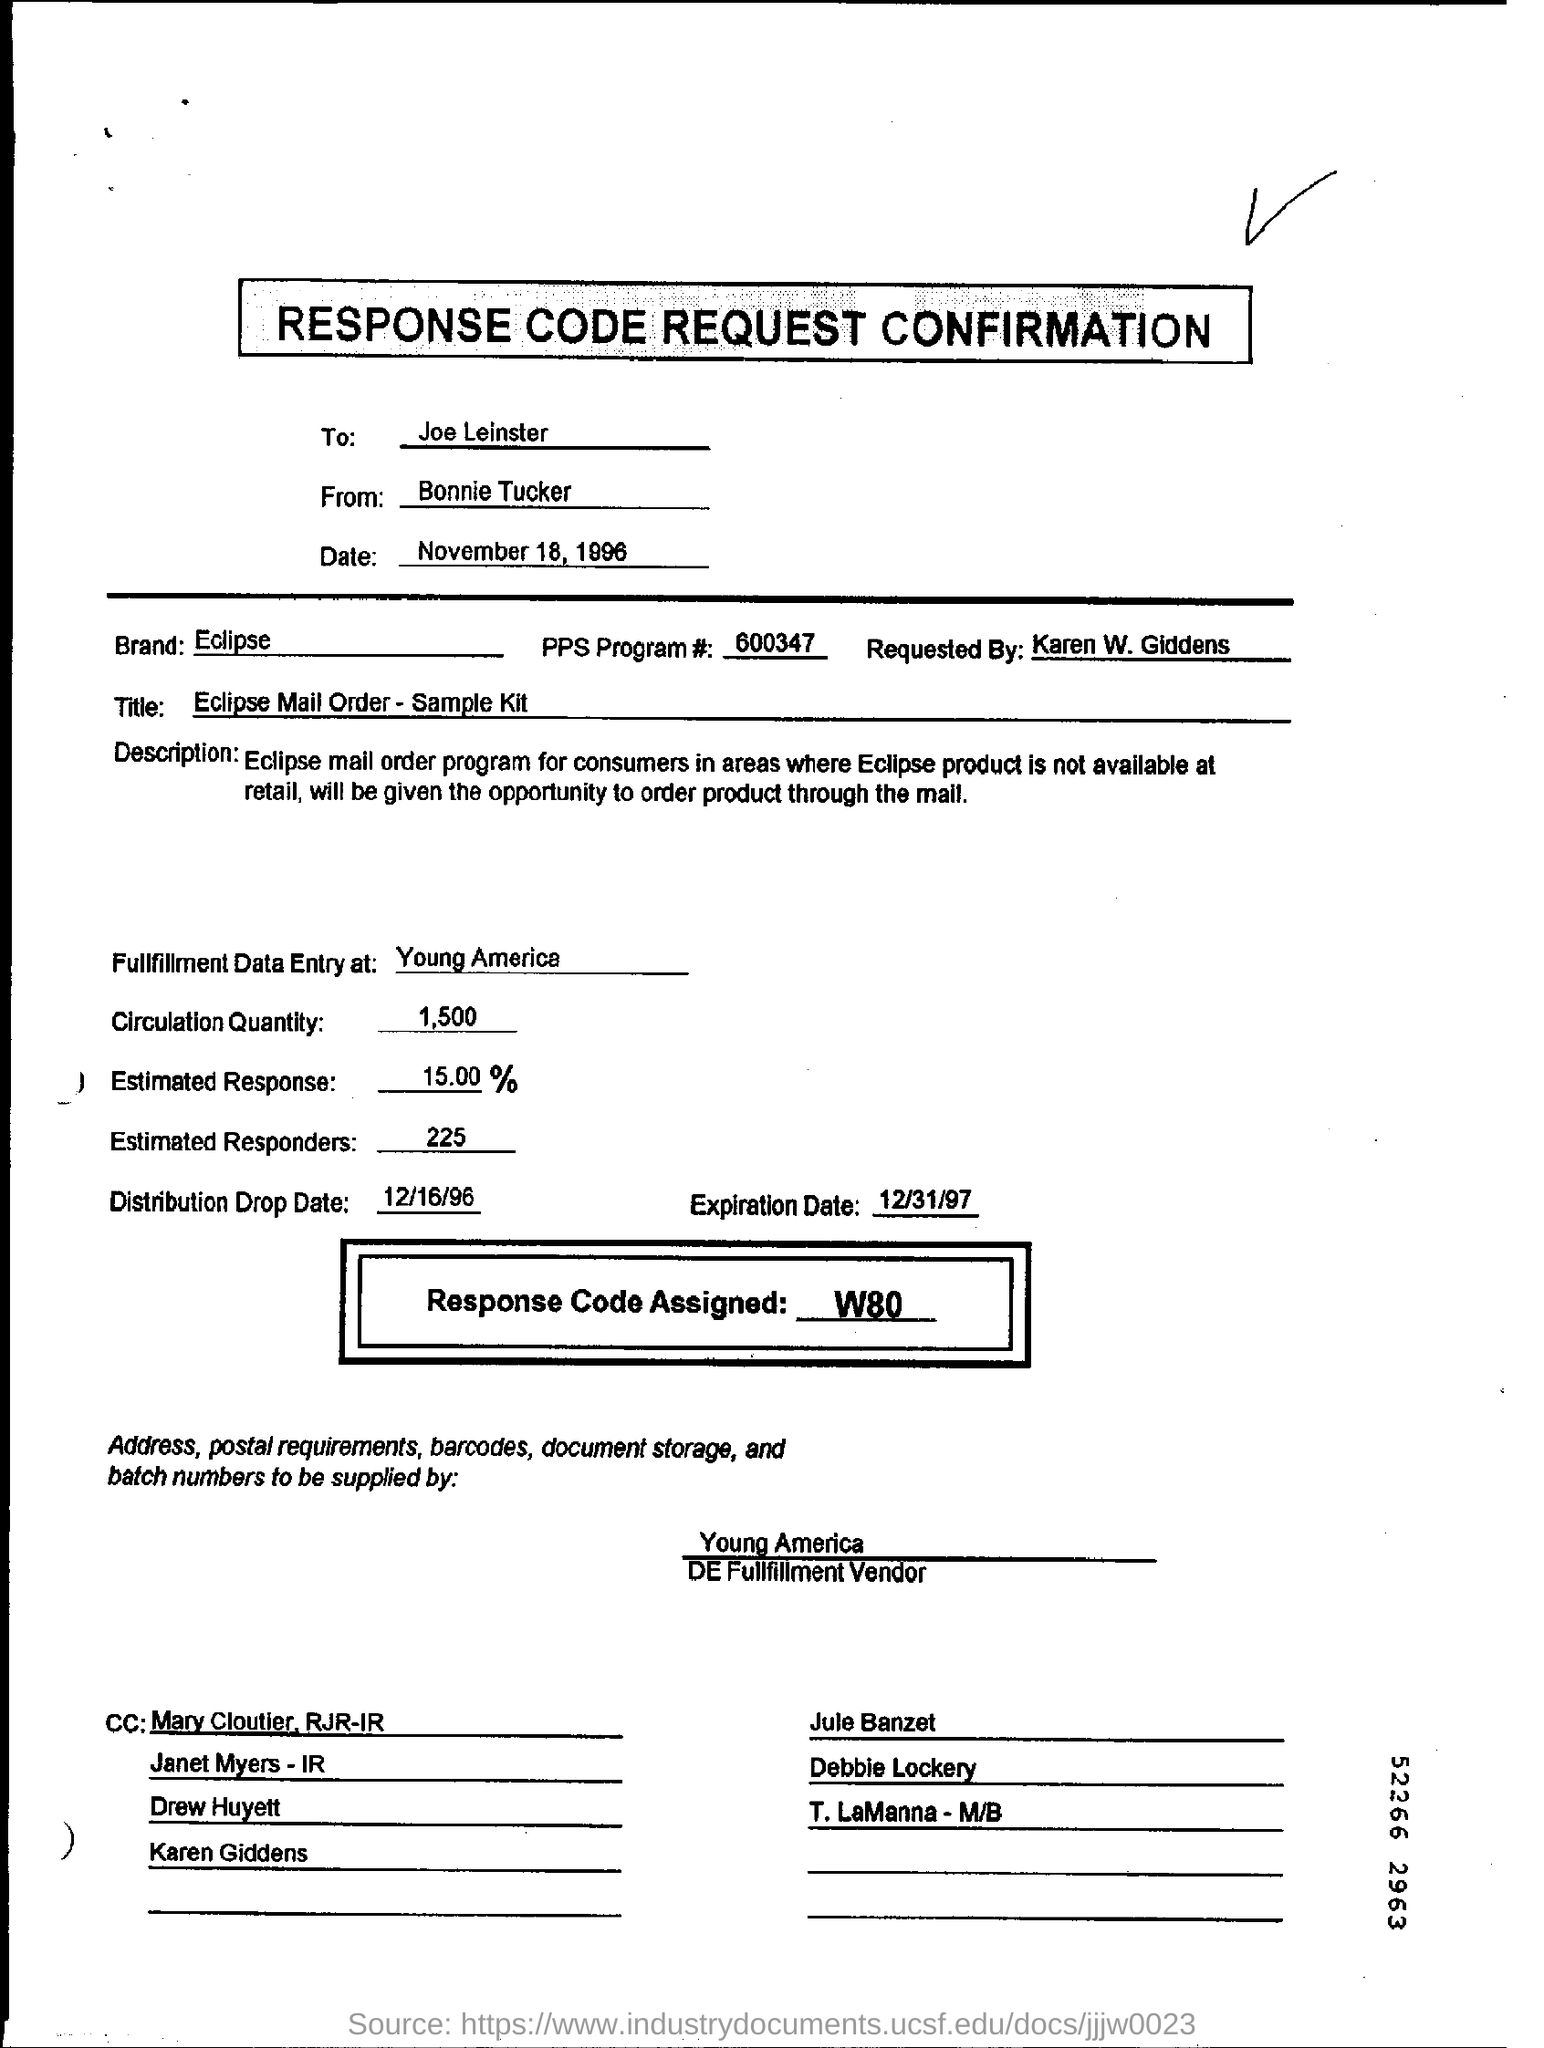Mention a couple of crucial points in this snapshot. The estimated response is 15.00%. The date mentioned in the form is November 18, 1996. 